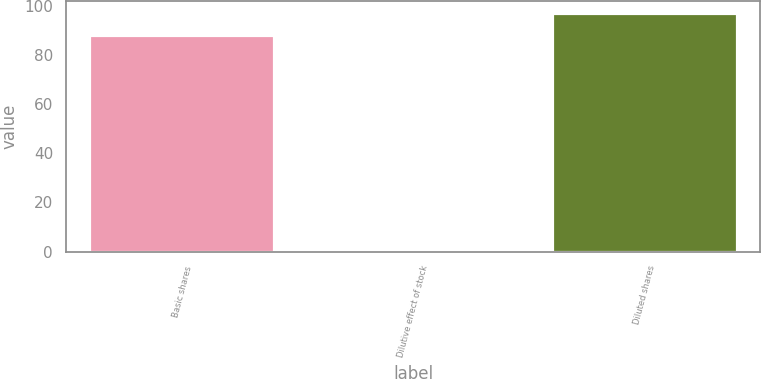Convert chart to OTSL. <chart><loc_0><loc_0><loc_500><loc_500><bar_chart><fcel>Basic shares<fcel>Dilutive effect of stock<fcel>Diluted shares<nl><fcel>88.2<fcel>0.9<fcel>97.02<nl></chart> 